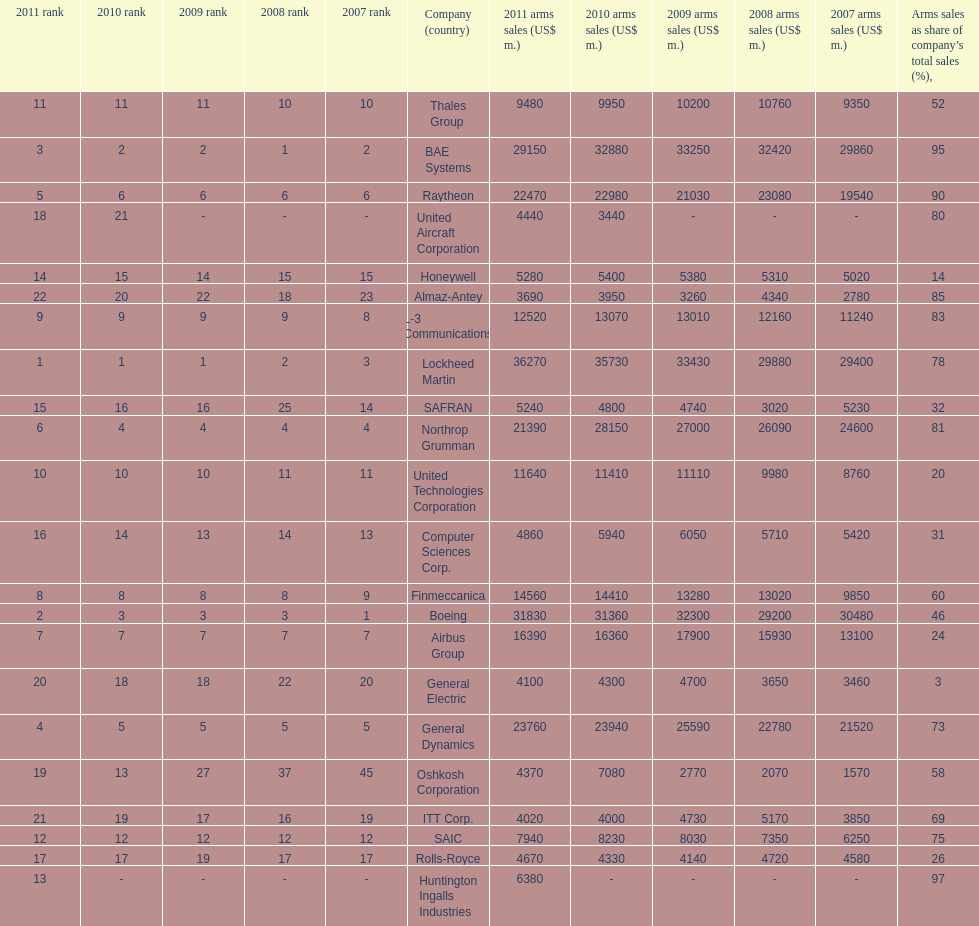How many different countries are listed? 6. 